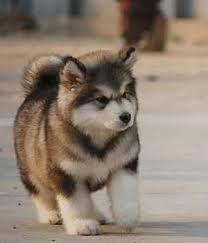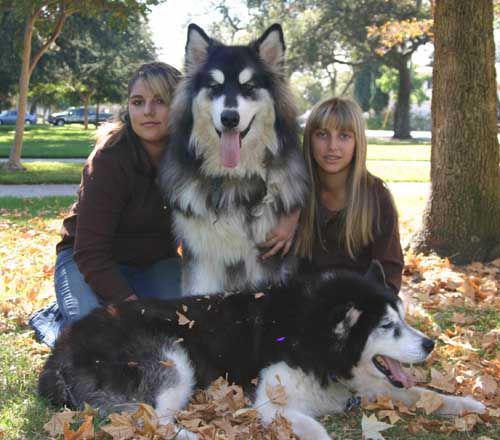The first image is the image on the left, the second image is the image on the right. Examine the images to the left and right. Is the description "There are more dogs in the image on the right." accurate? Answer yes or no. Yes. The first image is the image on the left, the second image is the image on the right. Examine the images to the left and right. Is the description "Each image includes at least one person sitting close to at least one dog in an indoor setting, and the right image shows dog and human on a sofa." accurate? Answer yes or no. No. 